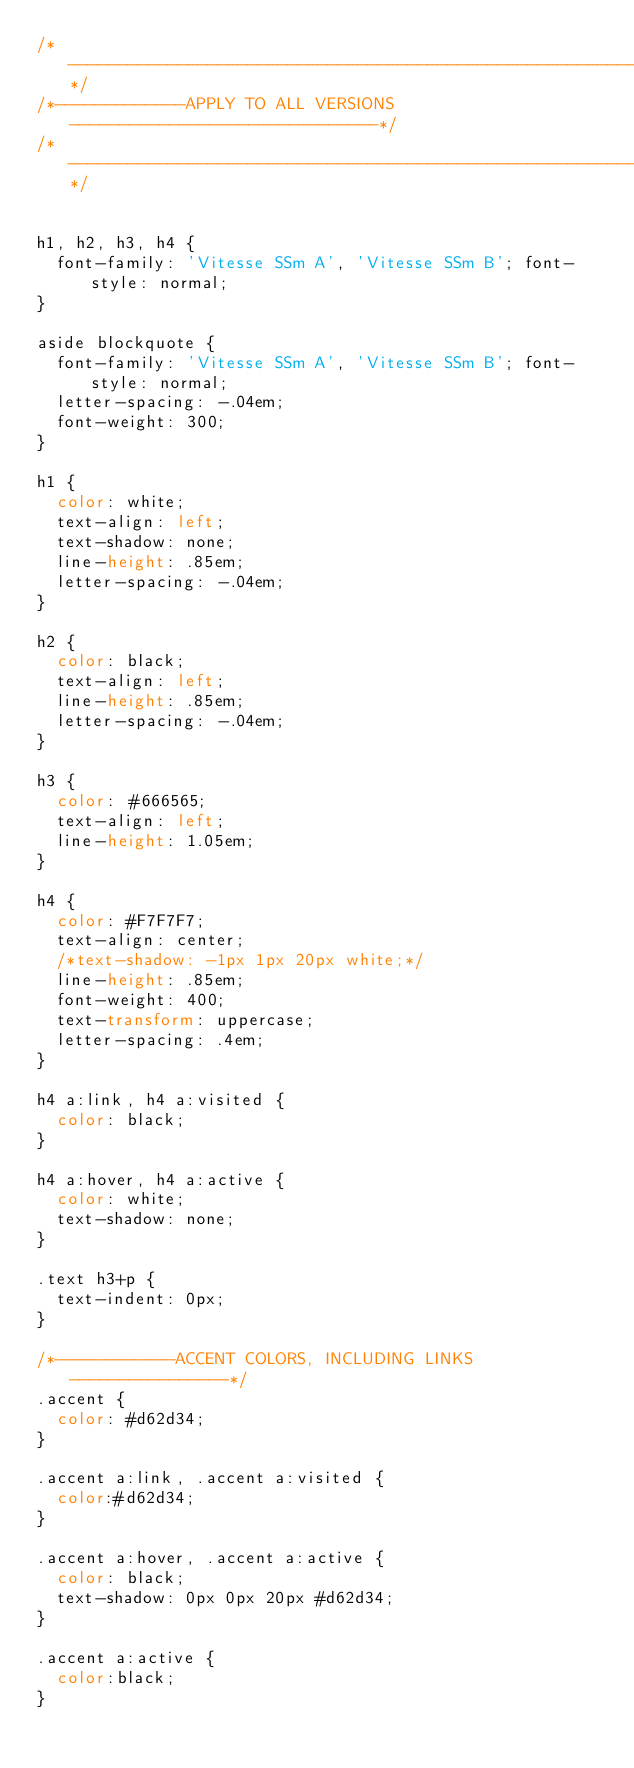<code> <loc_0><loc_0><loc_500><loc_500><_CSS_>/*-----------------------------------------------------------------*/
/*-------------APPLY TO ALL VERSIONS-------------------------------*/
/*-----------------------------------------------------------------*/


h1, h2, h3, h4 {
  font-family: 'Vitesse SSm A', 'Vitesse SSm B'; font-style: normal;
}

aside blockquote {
  font-family: 'Vitesse SSm A', 'Vitesse SSm B'; font-style: normal;
  letter-spacing: -.04em;
  font-weight: 300;
}

h1 {
  color: white;
  text-align: left;
  text-shadow: none;
  line-height: .85em;
  letter-spacing: -.04em;
}

h2 {
  color: black;
  text-align: left;
  line-height: .85em;
  letter-spacing: -.04em;
}

h3 {
  color: #666565;
  text-align: left;
  line-height: 1.05em;
}

h4 {
  color: #F7F7F7;
  text-align: center;
  /*text-shadow: -1px 1px 20px white;*/
  line-height: .85em;
  font-weight: 400;
  text-transform: uppercase;
  letter-spacing: .4em;
}

h4 a:link, h4 a:visited {
  color: black;
}

h4 a:hover, h4 a:active {
  color: white;
  text-shadow: none;
}

.text h3+p {
  text-indent: 0px;
}

/*------------ACCENT COLORS, INCLUDING LINKS----------------*/
.accent {
  color: #d62d34;
}

.accent a:link, .accent a:visited {
  color:#d62d34;
}

.accent a:hover, .accent a:active {
  color: black;
  text-shadow: 0px 0px 20px #d62d34;
}

.accent a:active {
  color:black;
}
</code> 